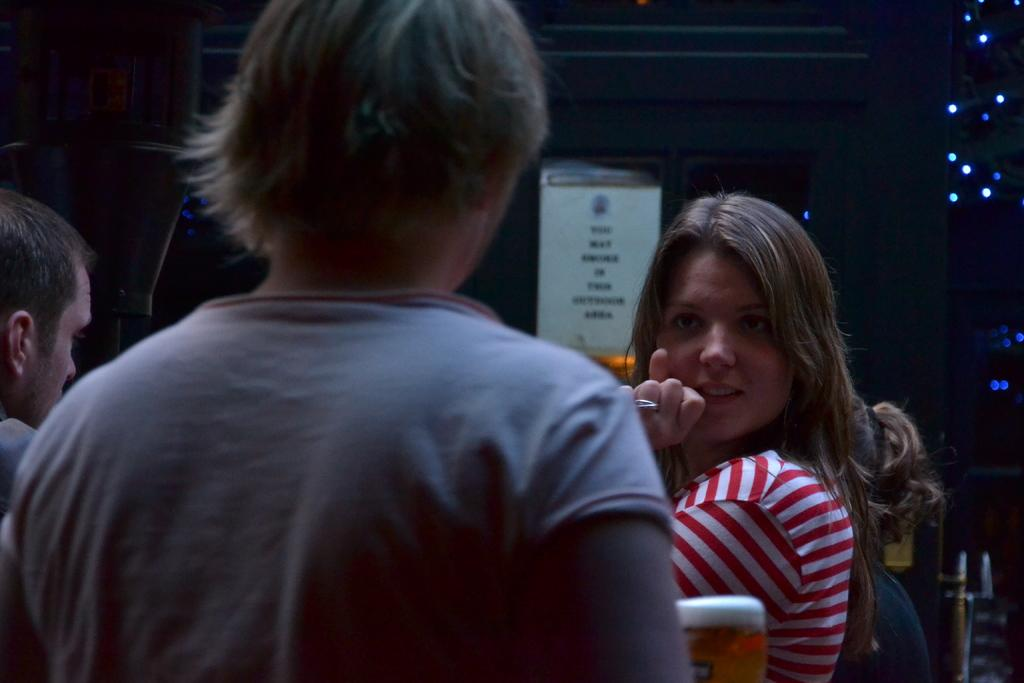Who is the main subject in the image? There is a woman in the image. What is the woman wearing? The woman is wearing a red and white striped t-shirt. What is the woman's posture and expression in the image? The woman is standing and looking straight. Who else is present in the image? There is a boy in the image. What can be observed about the background of the image? The background of the image is dark. What type of badge is the woman wearing in the image? There is no badge visible on the woman in the image. What is the woman's reaction to the fear in the image? There is no fear depicted in the image, and the woman's expression is neutral. 